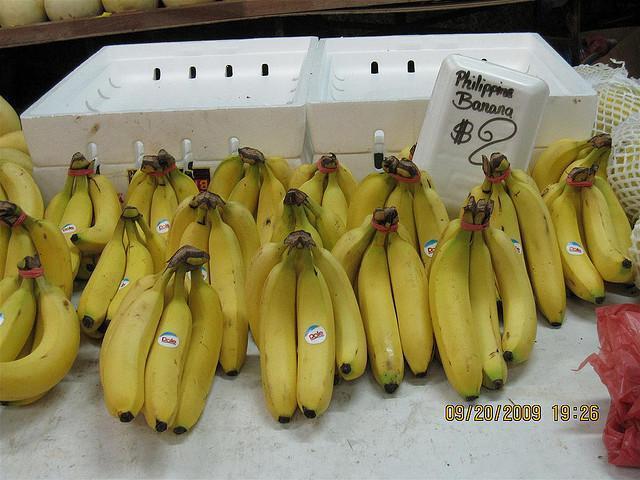How many bananas are in the photo?
Give a very brief answer. 12. How many giraffes are leaning over the woman's left shoulder?
Give a very brief answer. 0. 